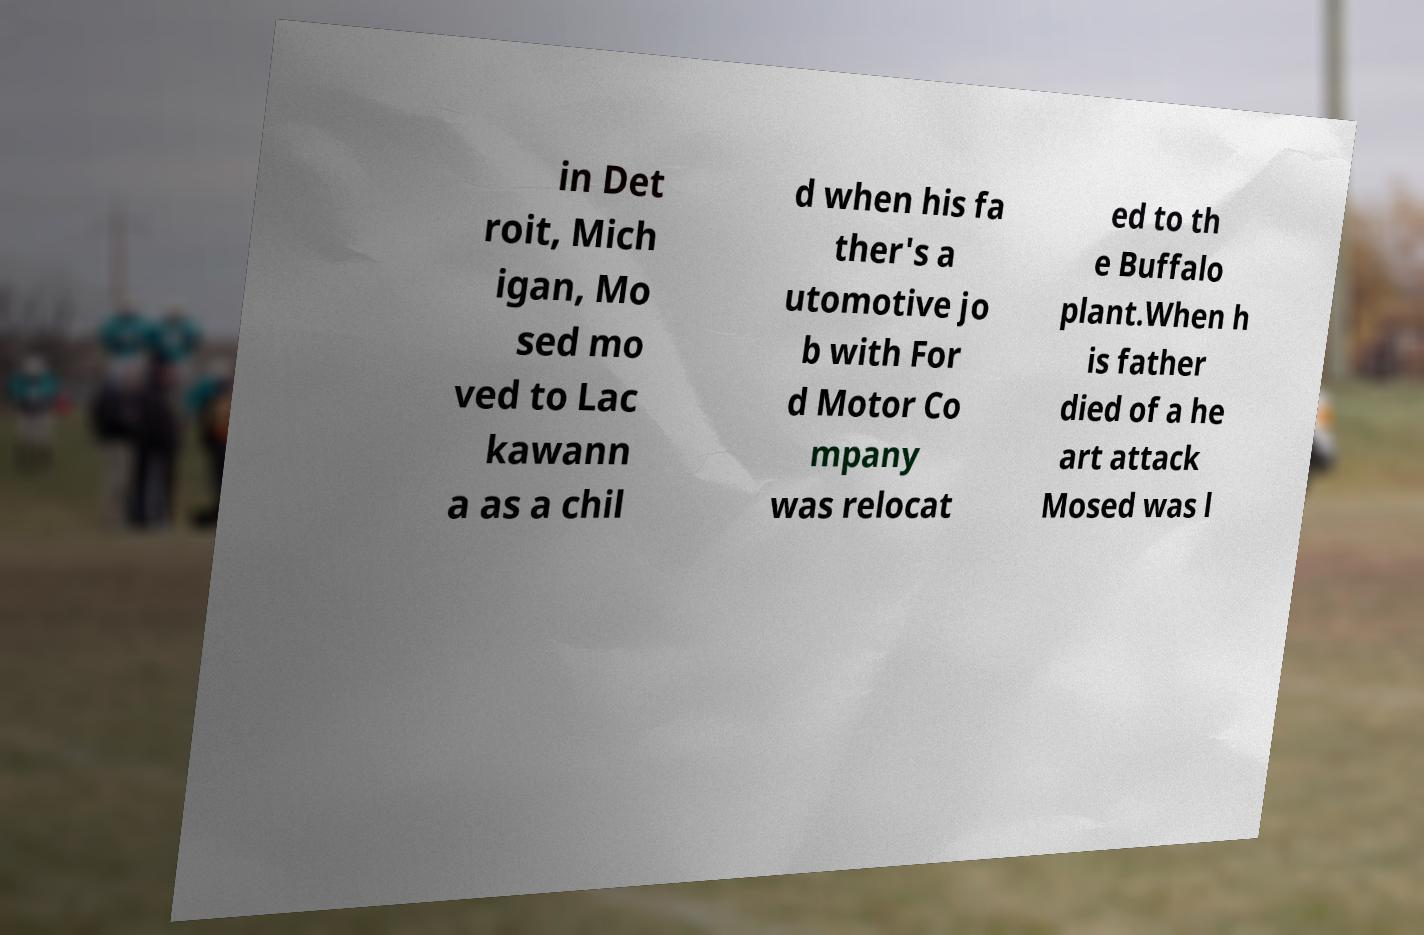Please identify and transcribe the text found in this image. in Det roit, Mich igan, Mo sed mo ved to Lac kawann a as a chil d when his fa ther's a utomotive jo b with For d Motor Co mpany was relocat ed to th e Buffalo plant.When h is father died of a he art attack Mosed was l 